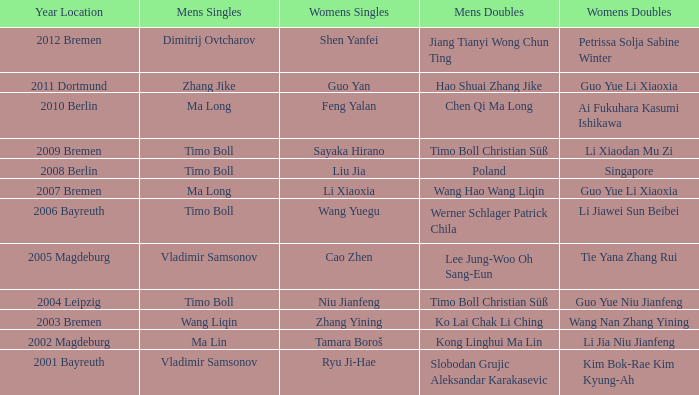Who won Womens Singles in the year that Ma Lin won Mens Singles? Tamara Boroš. 